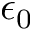<formula> <loc_0><loc_0><loc_500><loc_500>\epsilon _ { 0 }</formula> 